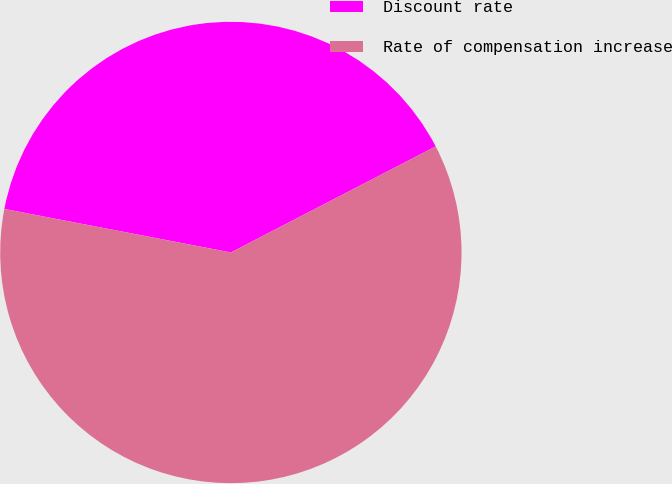<chart> <loc_0><loc_0><loc_500><loc_500><pie_chart><fcel>Discount rate<fcel>Rate of compensation increase<nl><fcel>39.37%<fcel>60.63%<nl></chart> 